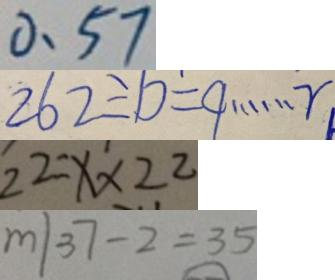<formula> <loc_0><loc_0><loc_500><loc_500>0 . 5 7 
 2 6 2 \div b = 9 \cdots r 
 2 2 = x \times 2 2 
 m \vert 3 7 - 2 = 3 5</formula> 